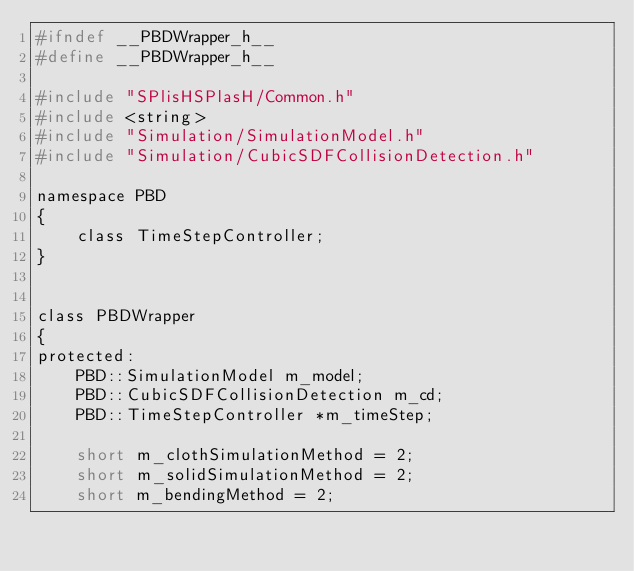Convert code to text. <code><loc_0><loc_0><loc_500><loc_500><_C_>#ifndef __PBDWrapper_h__
#define __PBDWrapper_h__

#include "SPlisHSPlasH/Common.h"
#include <string>
#include "Simulation/SimulationModel.h"
#include "Simulation/CubicSDFCollisionDetection.h"

namespace PBD
{
	class TimeStepController;
}


class PBDWrapper
{
protected:
	PBD::SimulationModel m_model;
	PBD::CubicSDFCollisionDetection m_cd;
	PBD::TimeStepController *m_timeStep;

	short m_clothSimulationMethod = 2;
	short m_solidSimulationMethod = 2;
	short m_bendingMethod = 2;</code> 